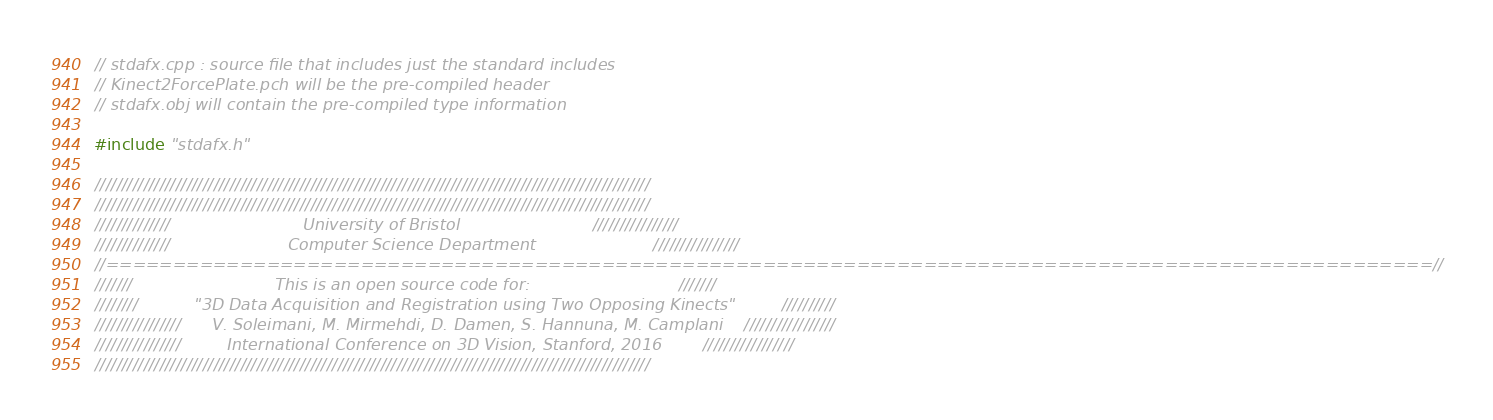Convert code to text. <code><loc_0><loc_0><loc_500><loc_500><_C++_>// stdafx.cpp : source file that includes just the standard includes
// Kinect2ForcePlate.pch will be the pre-compiled header
// stdafx.obj will contain the pre-compiled type information

#include "stdafx.h"

///////////////////////////////////////////////////////////////////////////////////////////////////////
///////////////////////////////////////////////////////////////////////////////////////////////////////
//////////////                          University of Bristol                          ////////////////
//////////////                       Computer Science Department                       ////////////////
//===================================================================================================//
///////                            This is an open source code for:                             ///////
////////           "3D Data Acquisition and Registration using Two Opposing Kinects"         //////////
////////////////      V. Soleimani, M. Mirmehdi, D. Damen, S. Hannuna, M. Camplani    /////////////////
////////////////         International Conference on 3D Vision, Stanford, 2016        /////////////////
///////////////////////////////////////////////////////////////////////////////////////////////////////

</code> 